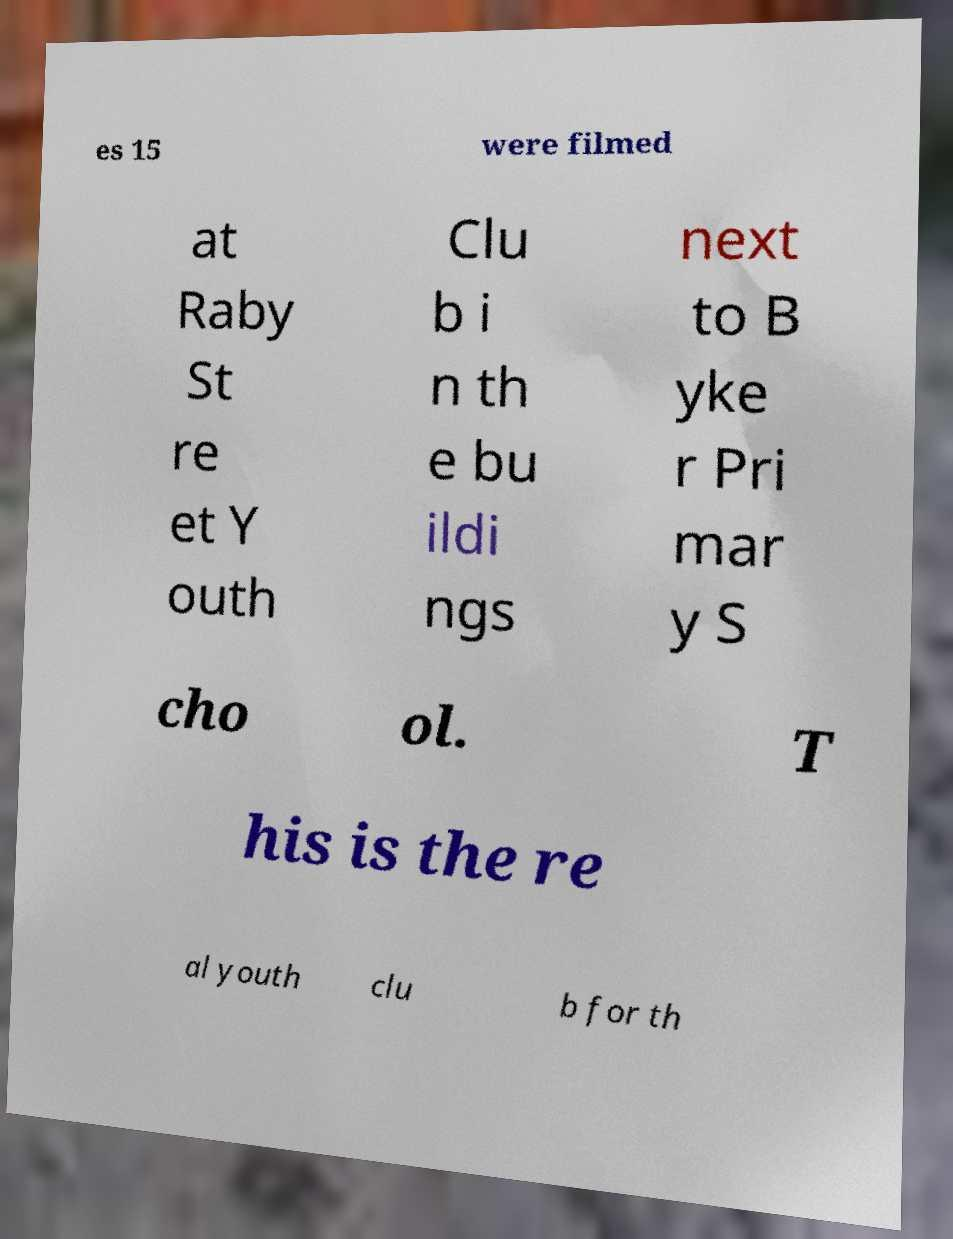What messages or text are displayed in this image? I need them in a readable, typed format. es 15 were filmed at Raby St re et Y outh Clu b i n th e bu ildi ngs next to B yke r Pri mar y S cho ol. T his is the re al youth clu b for th 